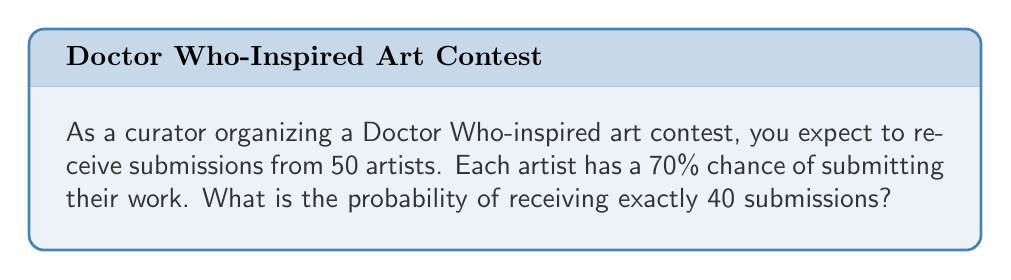Teach me how to tackle this problem. To solve this problem, we'll use the binomial probability distribution, as we have a fixed number of independent trials (artists) with two possible outcomes (submit or not submit) and a constant probability of success.

1. Identify the parameters:
   $n = 50$ (number of artists)
   $p = 0.70$ (probability of submission)
   $k = 40$ (desired number of submissions)

2. Use the binomial probability formula:
   $$P(X = k) = \binom{n}{k} p^k (1-p)^{n-k}$$

3. Calculate the binomial coefficient:
   $$\binom{50}{40} = \frac{50!}{40!(50-40)!} = \frac{50!}{40!10!} = 10,272,278,170$$

4. Substitute values into the formula:
   $$P(X = 40) = 10,272,278,170 \times (0.70)^{40} \times (1-0.70)^{50-40}$$
   $$= 10,272,278,170 \times (0.70)^{40} \times (0.30)^{10}$$

5. Calculate the result:
   $$= 10,272,278,170 \times 0.0000478864 \times 0.0000059049$$
   $$= 0.0290829$$

6. Round to four decimal places:
   $$= 0.0291$$

Therefore, the probability of receiving exactly 40 submissions is approximately 0.0291 or 2.91%.
Answer: 0.0291 